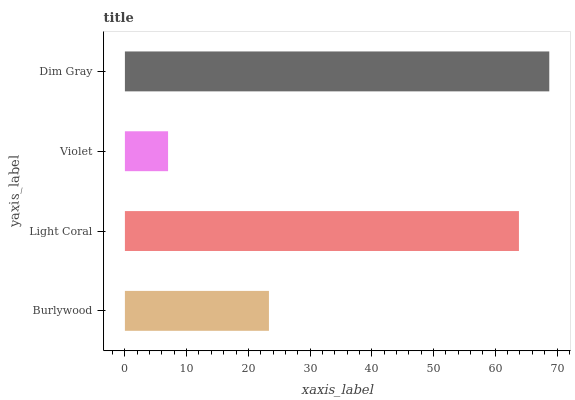Is Violet the minimum?
Answer yes or no. Yes. Is Dim Gray the maximum?
Answer yes or no. Yes. Is Light Coral the minimum?
Answer yes or no. No. Is Light Coral the maximum?
Answer yes or no. No. Is Light Coral greater than Burlywood?
Answer yes or no. Yes. Is Burlywood less than Light Coral?
Answer yes or no. Yes. Is Burlywood greater than Light Coral?
Answer yes or no. No. Is Light Coral less than Burlywood?
Answer yes or no. No. Is Light Coral the high median?
Answer yes or no. Yes. Is Burlywood the low median?
Answer yes or no. Yes. Is Burlywood the high median?
Answer yes or no. No. Is Dim Gray the low median?
Answer yes or no. No. 